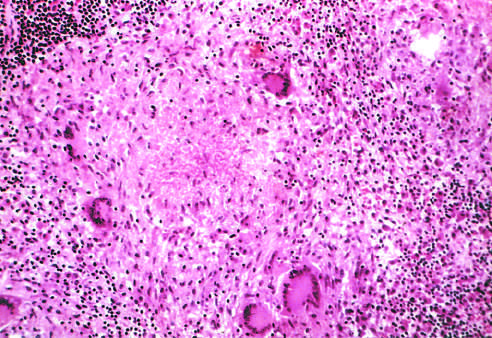what is surrounded by multiple multinucleate giant cells, epithelioid cells, and lymphocytes?
Answer the question using a single word or phrase. An area of central necrosis 